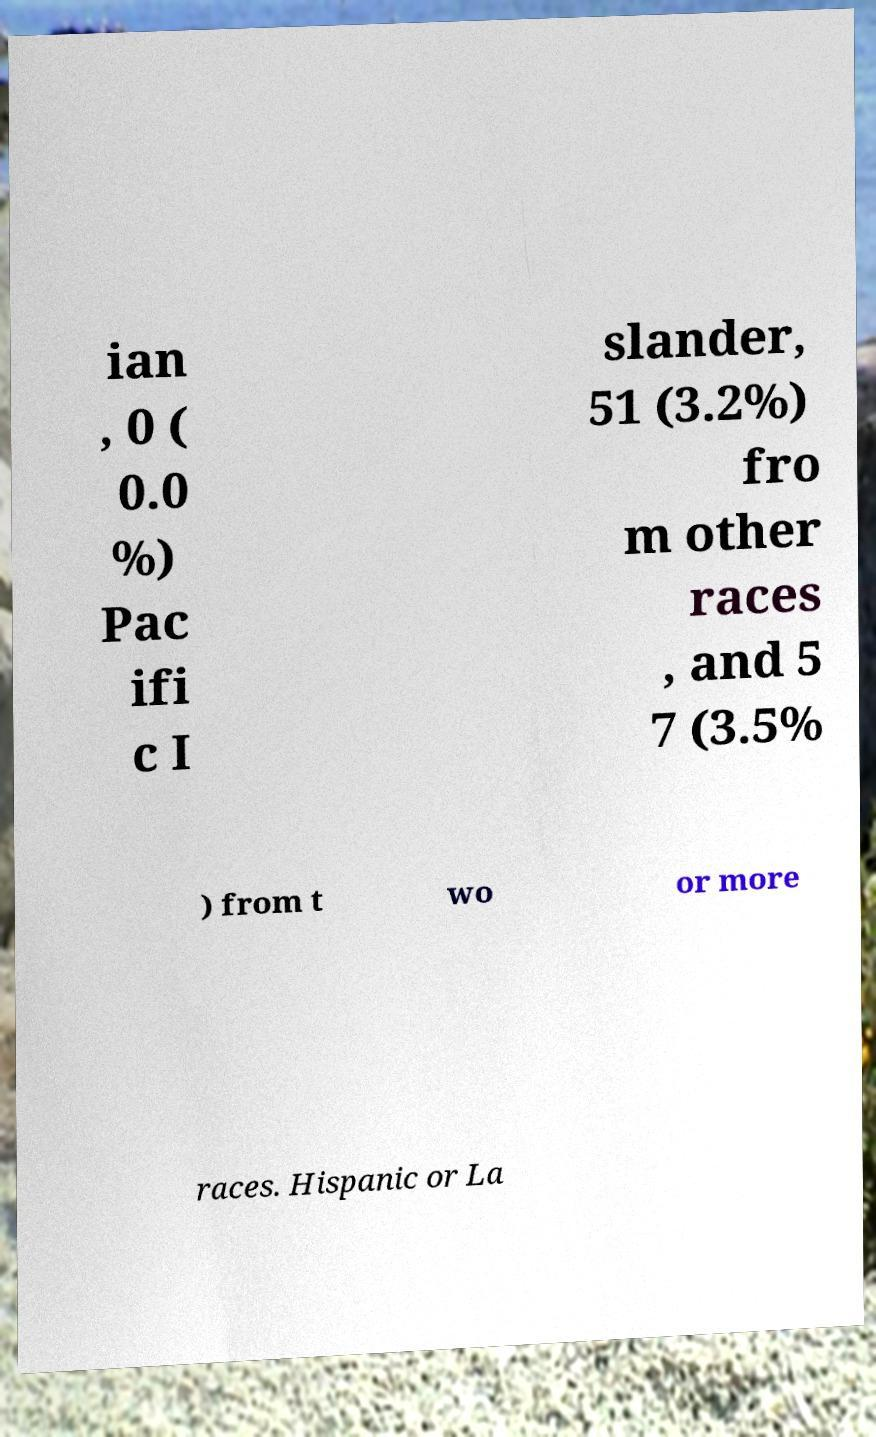Please read and relay the text visible in this image. What does it say? ian , 0 ( 0.0 %) Pac ifi c I slander, 51 (3.2%) fro m other races , and 5 7 (3.5% ) from t wo or more races. Hispanic or La 